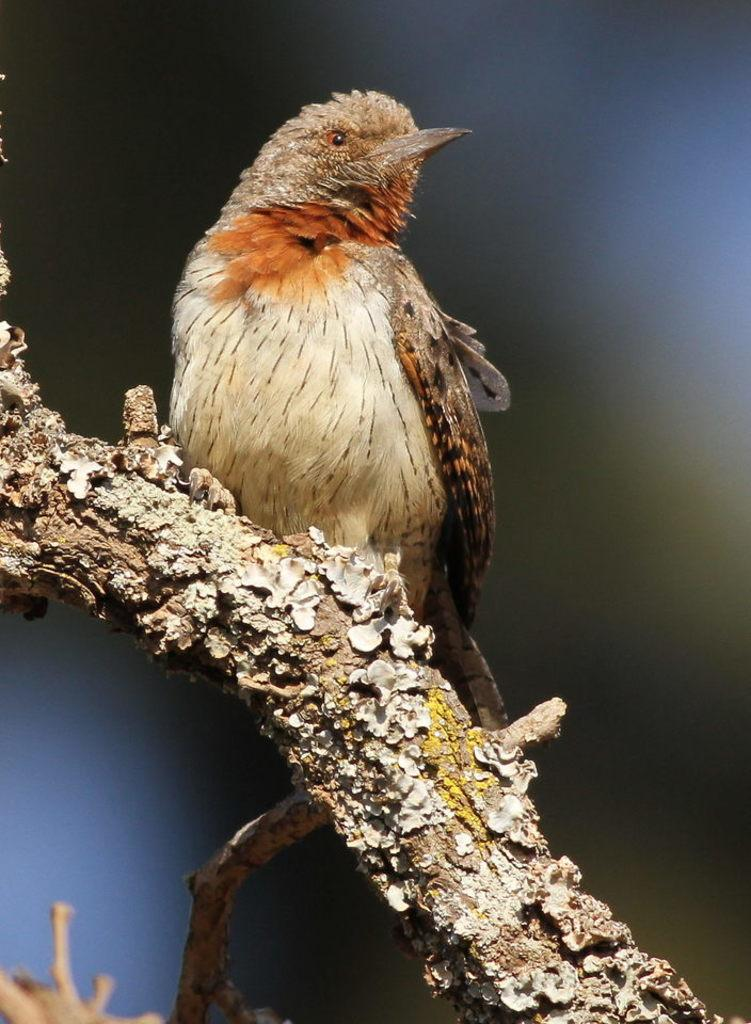What type of animal can be seen in the image? There is a bird in the image. Where is the bird located? The bird is on a branch. Can you describe the background of the image? The background of the image is blurred. What type of locket is hanging from the bird's neck in the image? There is no locket present in the image; it only features a bird on a branch with a blurred background. 